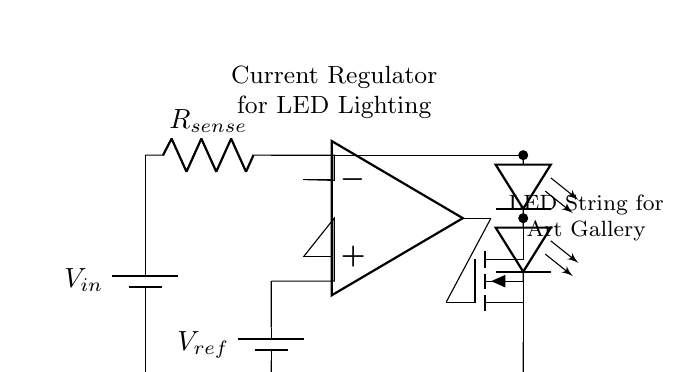What is the type of voltage source used in this circuit? The voltage source in the circuit is labeled as a battery, which indicates it supplies a direct voltage (DC) to the components.
Answer: Battery What component is used for current sensing? The component used for current sensing is labeled as a resistor in the circuit diagram, specifically designated as R sense, which measures the current flowing through the circuit.
Answer: R sense What type of transistor is implemented in this current regulator? The type of transistor shown in the circuit is a MOSFET, explicitly labeled as n-channel. This information is often represented by the symbol and notation in the circuit.
Answer: n-channel MOSFET What is the role of the operational amplifier in this circuit? The operational amplifier (op-amp) serves to compare the voltage across the sensing resistor with a reference voltage, and it regulates the gate voltage of the MOSFET to maintain the desired current through the LED string.
Answer: Regulation How does the reference voltage influence the output? The reference voltage plays a crucial role in setting the desired output current; by adjusting this voltage, one can control the current flowing through the LEDs, which is critical for their illumination and lifespan.
Answer: Controls current What is the purpose of the LED string in this circuit? The LED string is designed to provide illumination, specifically for the art gallery setting; it represents the load that the current regulator will supply with stable current to ensure consistent brightness and performance.
Answer: Illumination 